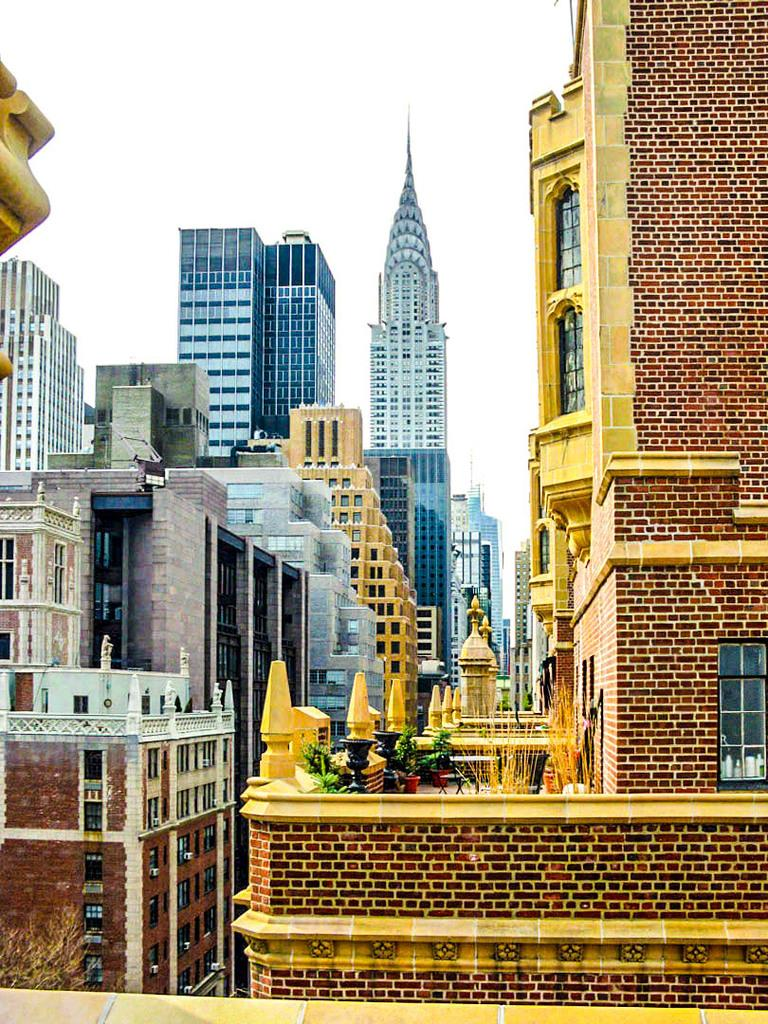What type of structures can be seen in the image? There are buildings in the image. What else is present in the image besides buildings? There are plants and other objects in the image. What can be seen in the background of the image? The sky is visible in the background of the image. What is the surface that the objects are placed on in the image? The surface is present at the bottom of the image. What type of voice can be heard coming from the plants in the image? There is no voice coming from the plants in the image, as plants do not have the ability to produce or emit sounds. 